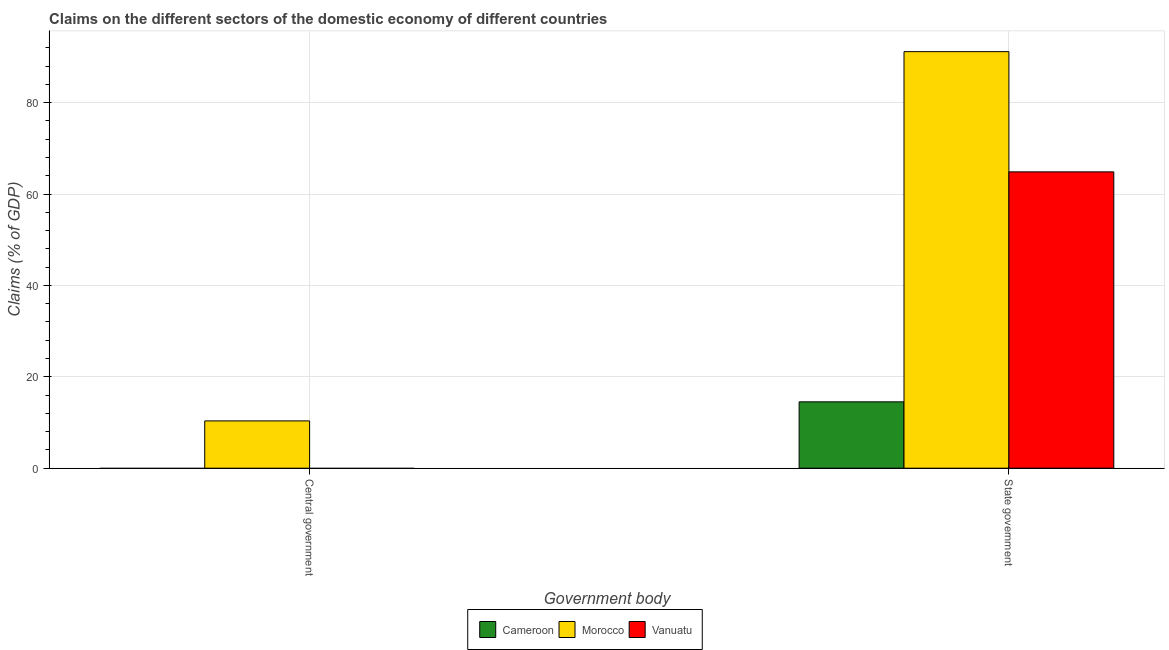How many bars are there on the 1st tick from the right?
Your answer should be compact. 3. What is the label of the 1st group of bars from the left?
Your response must be concise. Central government. What is the claims on state government in Cameroon?
Make the answer very short. 14.52. Across all countries, what is the maximum claims on state government?
Keep it short and to the point. 91.16. Across all countries, what is the minimum claims on state government?
Provide a short and direct response. 14.52. In which country was the claims on state government maximum?
Give a very brief answer. Morocco. What is the total claims on state government in the graph?
Offer a very short reply. 170.53. What is the difference between the claims on state government in Cameroon and that in Morocco?
Provide a succinct answer. -76.64. What is the difference between the claims on state government in Vanuatu and the claims on central government in Cameroon?
Keep it short and to the point. 64.85. What is the average claims on central government per country?
Your answer should be compact. 3.45. What is the difference between the claims on central government and claims on state government in Morocco?
Provide a short and direct response. -80.81. In how many countries, is the claims on central government greater than 68 %?
Give a very brief answer. 0. What is the ratio of the claims on state government in Vanuatu to that in Cameroon?
Your answer should be very brief. 4.47. In how many countries, is the claims on state government greater than the average claims on state government taken over all countries?
Your answer should be very brief. 2. How many countries are there in the graph?
Offer a very short reply. 3. What is the difference between two consecutive major ticks on the Y-axis?
Make the answer very short. 20. Does the graph contain grids?
Your answer should be very brief. Yes. Where does the legend appear in the graph?
Your answer should be compact. Bottom center. What is the title of the graph?
Offer a very short reply. Claims on the different sectors of the domestic economy of different countries. What is the label or title of the X-axis?
Keep it short and to the point. Government body. What is the label or title of the Y-axis?
Ensure brevity in your answer.  Claims (% of GDP). What is the Claims (% of GDP) of Cameroon in Central government?
Your answer should be very brief. 0. What is the Claims (% of GDP) of Morocco in Central government?
Your response must be concise. 10.35. What is the Claims (% of GDP) in Vanuatu in Central government?
Your response must be concise. 0. What is the Claims (% of GDP) of Cameroon in State government?
Your response must be concise. 14.52. What is the Claims (% of GDP) in Morocco in State government?
Ensure brevity in your answer.  91.16. What is the Claims (% of GDP) in Vanuatu in State government?
Give a very brief answer. 64.85. Across all Government body, what is the maximum Claims (% of GDP) in Cameroon?
Your response must be concise. 14.52. Across all Government body, what is the maximum Claims (% of GDP) in Morocco?
Give a very brief answer. 91.16. Across all Government body, what is the maximum Claims (% of GDP) in Vanuatu?
Make the answer very short. 64.85. Across all Government body, what is the minimum Claims (% of GDP) of Morocco?
Your response must be concise. 10.35. What is the total Claims (% of GDP) of Cameroon in the graph?
Your answer should be compact. 14.52. What is the total Claims (% of GDP) of Morocco in the graph?
Your answer should be compact. 101.51. What is the total Claims (% of GDP) in Vanuatu in the graph?
Offer a very short reply. 64.85. What is the difference between the Claims (% of GDP) of Morocco in Central government and that in State government?
Keep it short and to the point. -80.81. What is the difference between the Claims (% of GDP) of Morocco in Central government and the Claims (% of GDP) of Vanuatu in State government?
Give a very brief answer. -54.5. What is the average Claims (% of GDP) of Cameroon per Government body?
Provide a succinct answer. 7.26. What is the average Claims (% of GDP) of Morocco per Government body?
Make the answer very short. 50.75. What is the average Claims (% of GDP) in Vanuatu per Government body?
Make the answer very short. 32.42. What is the difference between the Claims (% of GDP) in Cameroon and Claims (% of GDP) in Morocco in State government?
Provide a short and direct response. -76.64. What is the difference between the Claims (% of GDP) of Cameroon and Claims (% of GDP) of Vanuatu in State government?
Provide a succinct answer. -50.33. What is the difference between the Claims (% of GDP) of Morocco and Claims (% of GDP) of Vanuatu in State government?
Provide a short and direct response. 26.31. What is the ratio of the Claims (% of GDP) in Morocco in Central government to that in State government?
Keep it short and to the point. 0.11. What is the difference between the highest and the second highest Claims (% of GDP) of Morocco?
Give a very brief answer. 80.81. What is the difference between the highest and the lowest Claims (% of GDP) of Cameroon?
Your response must be concise. 14.52. What is the difference between the highest and the lowest Claims (% of GDP) of Morocco?
Provide a succinct answer. 80.81. What is the difference between the highest and the lowest Claims (% of GDP) of Vanuatu?
Offer a very short reply. 64.85. 